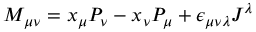<formula> <loc_0><loc_0><loc_500><loc_500>M _ { \mu \nu } = x _ { \mu } P _ { \nu } - x _ { \nu } P _ { \mu } + \epsilon _ { \mu \nu \lambda } J ^ { \lambda }</formula> 